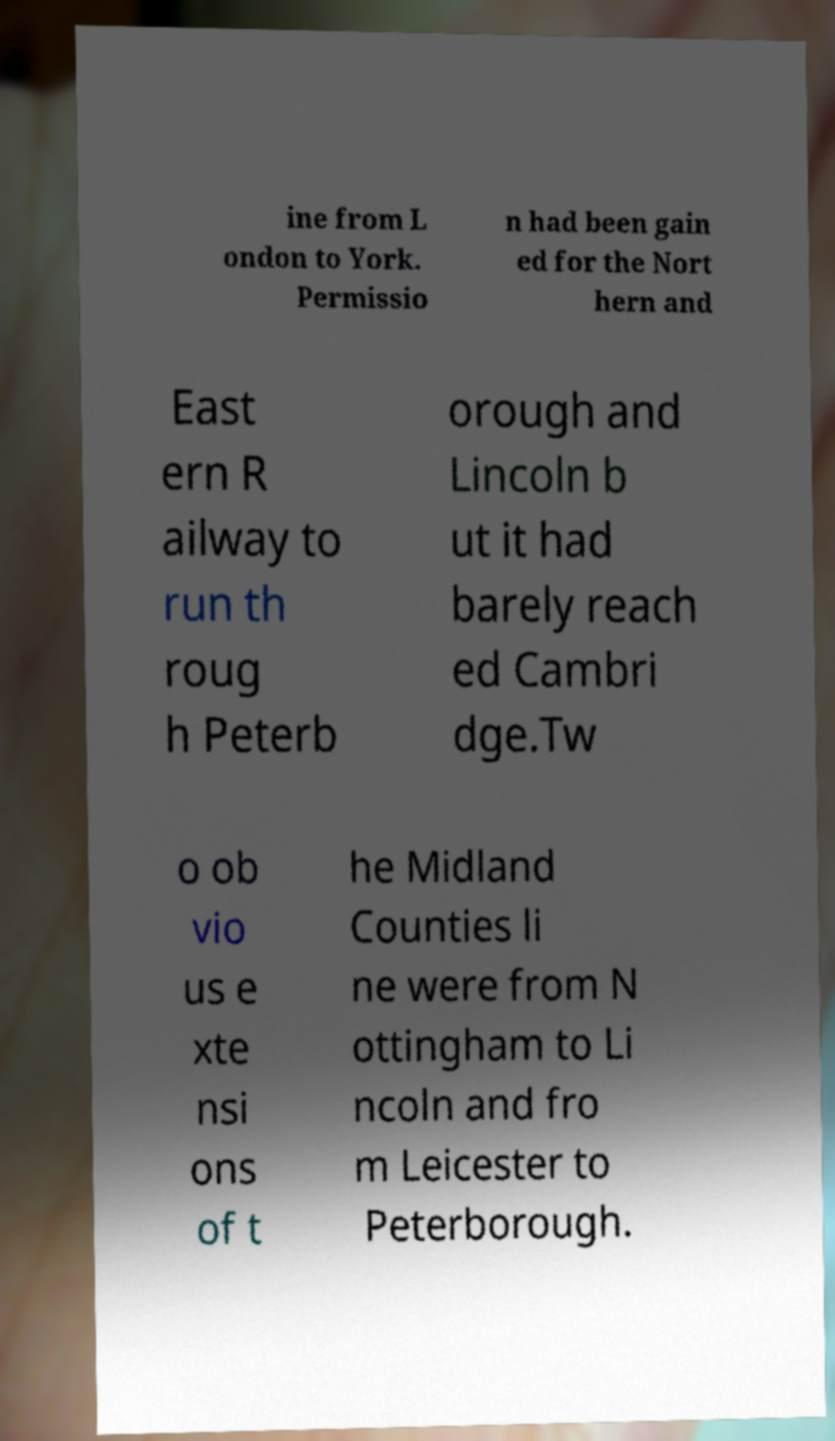I need the written content from this picture converted into text. Can you do that? ine from L ondon to York. Permissio n had been gain ed for the Nort hern and East ern R ailway to run th roug h Peterb orough and Lincoln b ut it had barely reach ed Cambri dge.Tw o ob vio us e xte nsi ons of t he Midland Counties li ne were from N ottingham to Li ncoln and fro m Leicester to Peterborough. 